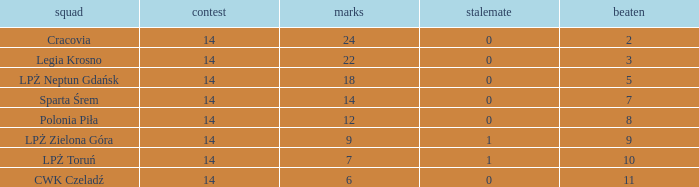I'm looking to parse the entire table for insights. Could you assist me with that? {'header': ['squad', 'contest', 'marks', 'stalemate', 'beaten'], 'rows': [['Cracovia', '14', '24', '0', '2'], ['Legia Krosno', '14', '22', '0', '3'], ['LPŻ Neptun Gdańsk', '14', '18', '0', '5'], ['Sparta Śrem', '14', '14', '0', '7'], ['Polonia Piła', '14', '12', '0', '8'], ['LPŻ Zielona Góra', '14', '9', '1', '9'], ['LPŻ Toruń', '14', '7', '1', '10'], ['CWK Czeladź', '14', '6', '0', '11']]} What is the highest loss with points less than 7? 11.0. 